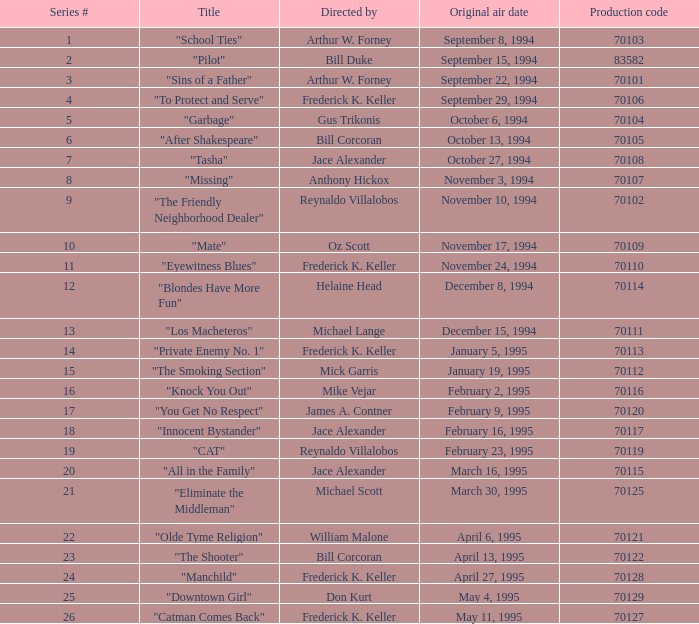For the "downtown girl" episode, what was the initial broadcast date? May 4, 1995. 